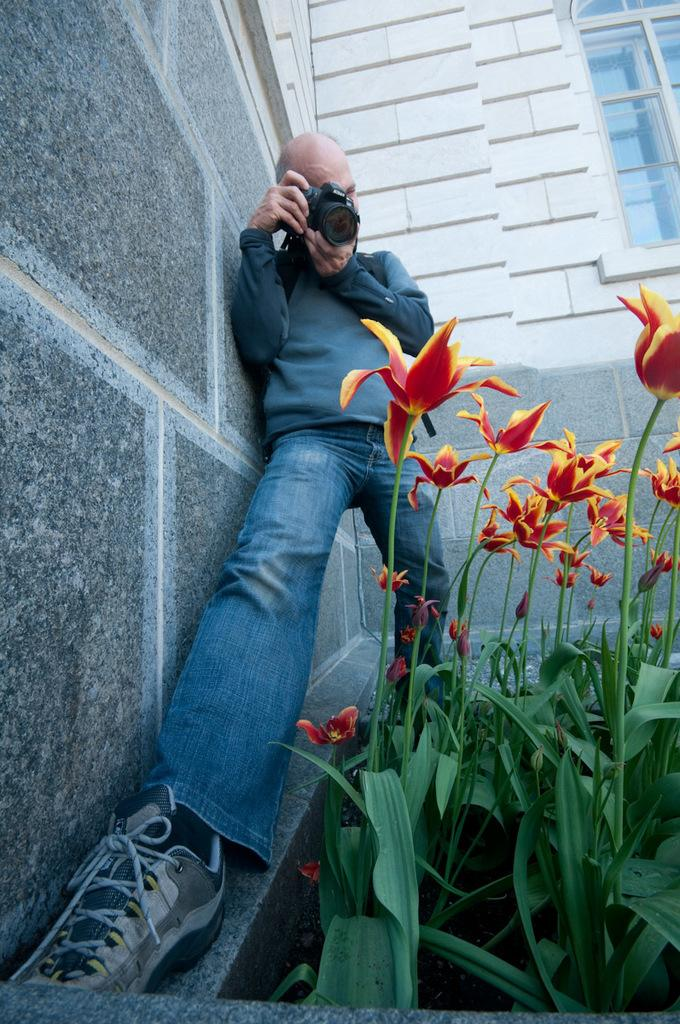What is the person in the image doing? The person in the image is taking pictures with a camera. What can be seen in the image besides the person with the camera? There are flowers, plants, a wall, and a window in the image. What type of vegetation is present in the image? There are flowers and plants in the image. What architectural feature can be seen in the image? There is a wall in the image. What is the purpose of the window in the image? The window allows light to enter the space and provides a view of the outdoors. Where is the faucet located in the image? There is no faucet present in the image. What type of growth is the minister experiencing in the image? There is no minister or growth present in the image. 